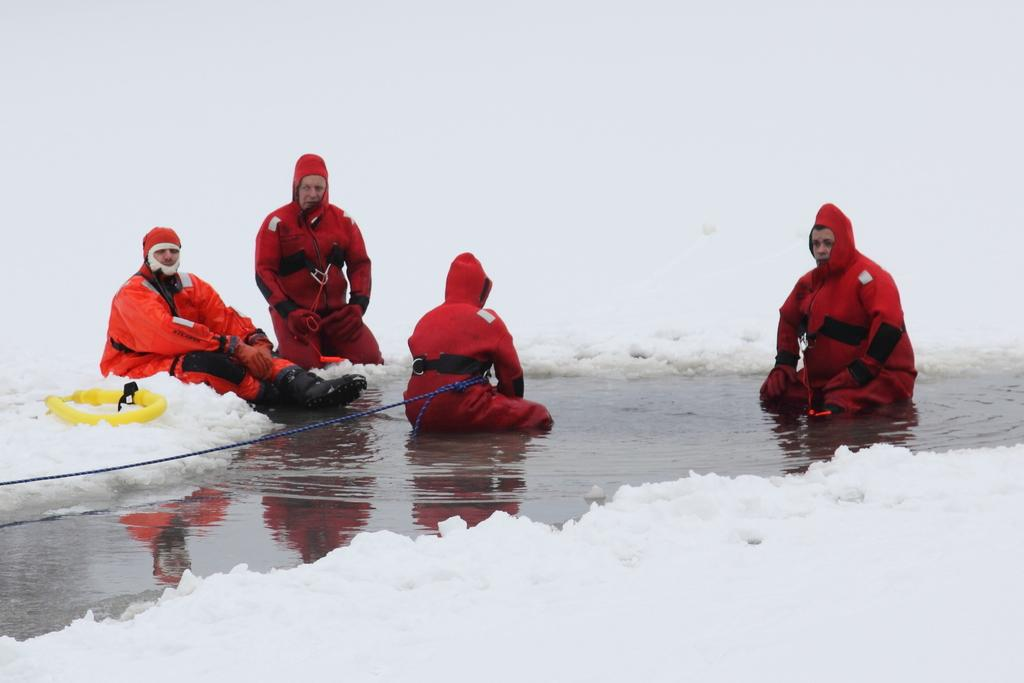What are the people in the image doing? The people in the image are sitting in the center. What is the ground made of in the image? There is snow at the bottom of the image. Is there any water visible in the image? Yes, there is a small pond at the bottom of the image. What type of ant can be seen playing an instrument in the image? There are no ants or instruments present in the image. 